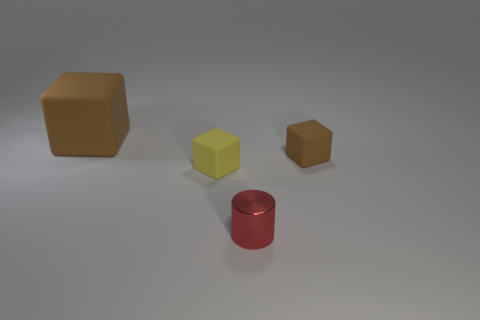What is the object that is in front of the tiny brown thing and on the left side of the small red cylinder made of?
Keep it short and to the point. Rubber. What is the size of the brown matte thing to the left of the tiny matte thing that is in front of the brown rubber thing that is in front of the big thing?
Give a very brief answer. Large. There is a tiny brown object; is it the same shape as the brown matte thing that is to the left of the yellow matte object?
Offer a terse response. Yes. What number of brown objects are both on the right side of the shiny cylinder and left of the red shiny object?
Provide a succinct answer. 0. How many yellow things are big matte blocks or matte things?
Ensure brevity in your answer.  1. Is the color of the block to the right of the small red object the same as the large matte cube behind the red cylinder?
Make the answer very short. Yes. The tiny metal object on the right side of the tiny cube left of the thing on the right side of the small red cylinder is what color?
Provide a succinct answer. Red. There is a matte object that is behind the tiny brown block; are there any small shiny cylinders that are behind it?
Offer a very short reply. No. There is a brown thing behind the tiny brown matte thing; is its shape the same as the small brown object?
Your answer should be compact. Yes. Are there any other things that are the same shape as the tiny shiny thing?
Provide a succinct answer. No. 